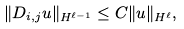<formula> <loc_0><loc_0><loc_500><loc_500>\| D _ { i , j } u \| _ { H ^ { \ell - 1 } } \leq C \| u \| _ { H ^ { \ell } } ,</formula> 